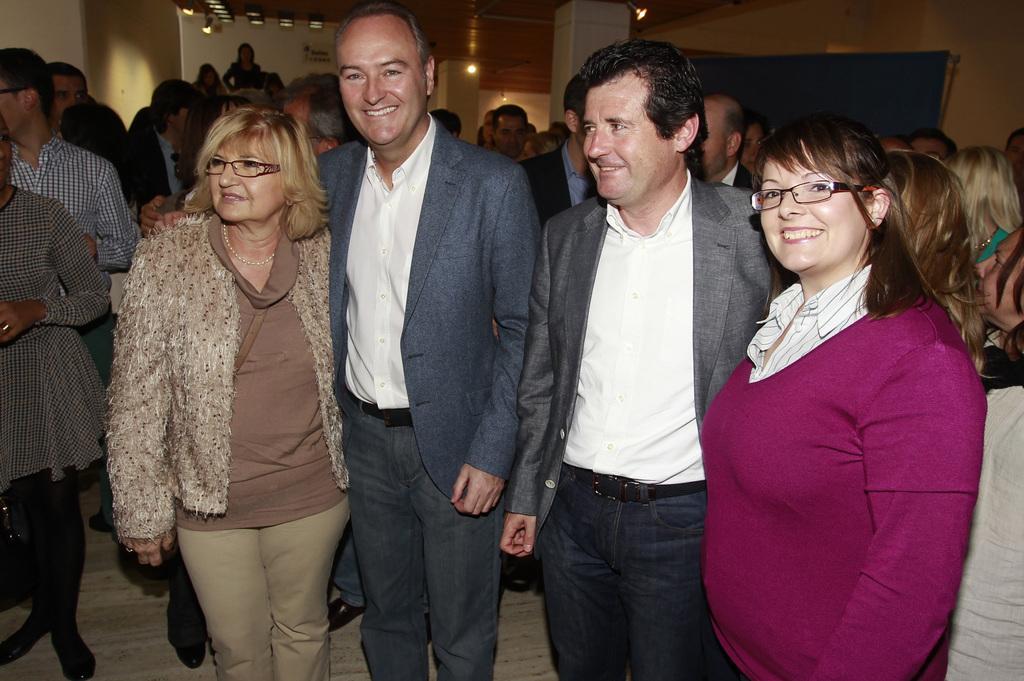Describe this image in one or two sentences. In this picture there is a group of men and women smiling and giving the pose into the camera. Behind there are some group of persons discussing something with each other. In the background we can see yellow color wall. 